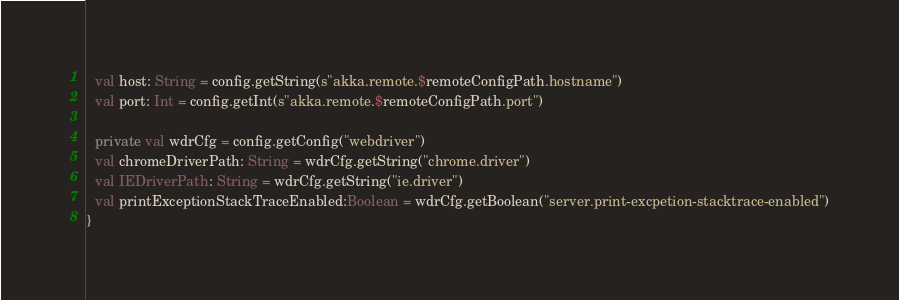Convert code to text. <code><loc_0><loc_0><loc_500><loc_500><_Scala_>  val host: String = config.getString(s"akka.remote.$remoteConfigPath.hostname")
  val port: Int = config.getInt(s"akka.remote.$remoteConfigPath.port")

  private val wdrCfg = config.getConfig("webdriver")
  val chromeDriverPath: String = wdrCfg.getString("chrome.driver")
  val IEDriverPath: String = wdrCfg.getString("ie.driver")
  val printExceptionStackTraceEnabled:Boolean = wdrCfg.getBoolean("server.print-excpetion-stacktrace-enabled")
}
</code> 